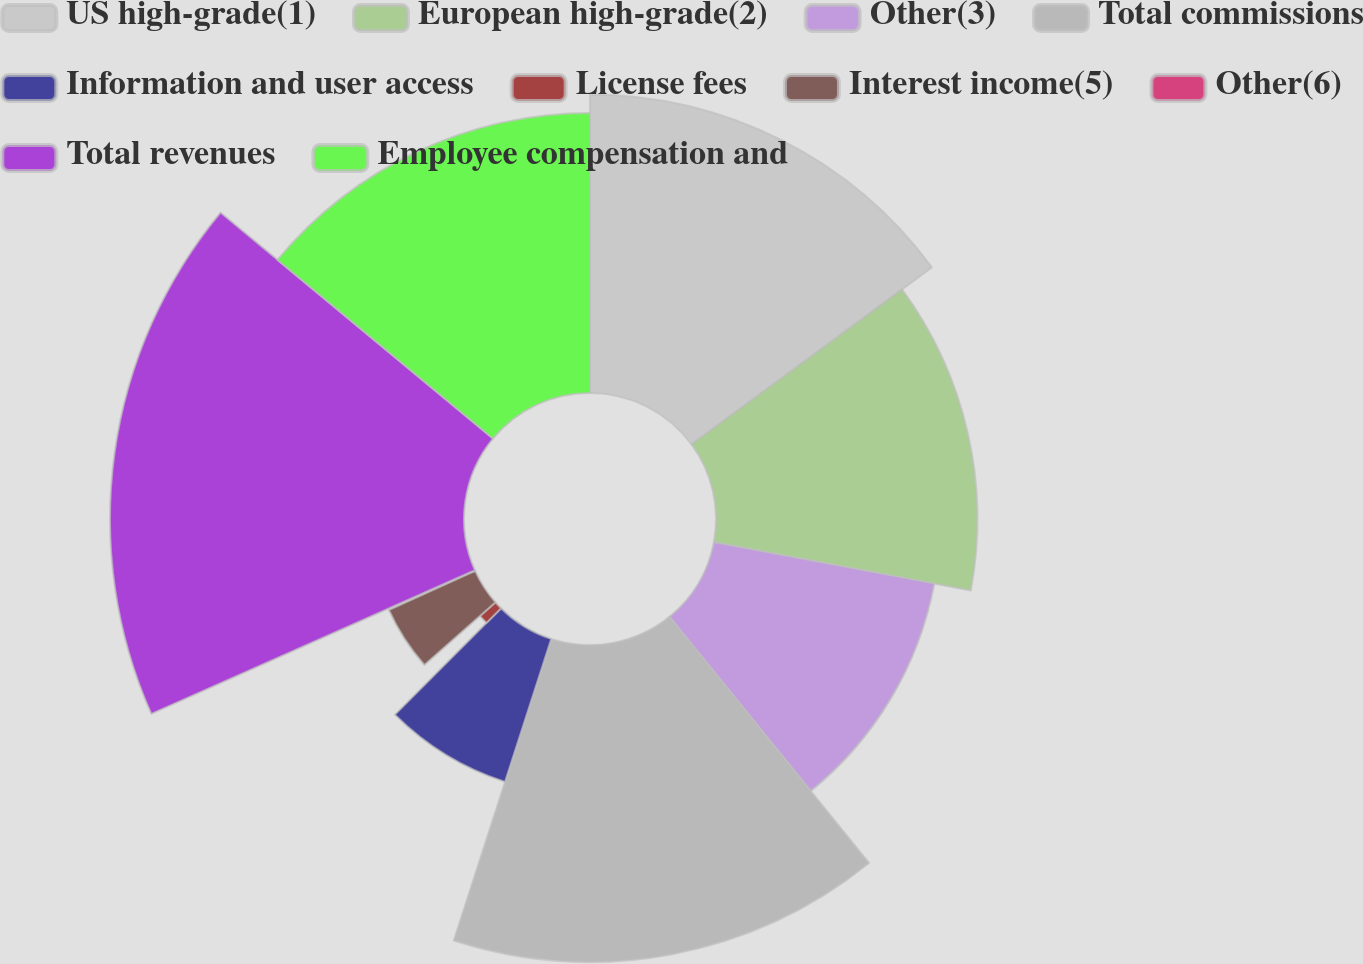<chart> <loc_0><loc_0><loc_500><loc_500><pie_chart><fcel>US high-grade(1)<fcel>European high-grade(2)<fcel>Other(3)<fcel>Total commissions<fcel>Information and user access<fcel>License fees<fcel>Interest income(5)<fcel>Other(6)<fcel>Total revenues<fcel>Employee compensation and<nl><fcel>14.9%<fcel>13.05%<fcel>11.2%<fcel>15.82%<fcel>7.5%<fcel>1.03%<fcel>4.73%<fcel>0.11%<fcel>17.67%<fcel>13.98%<nl></chart> 